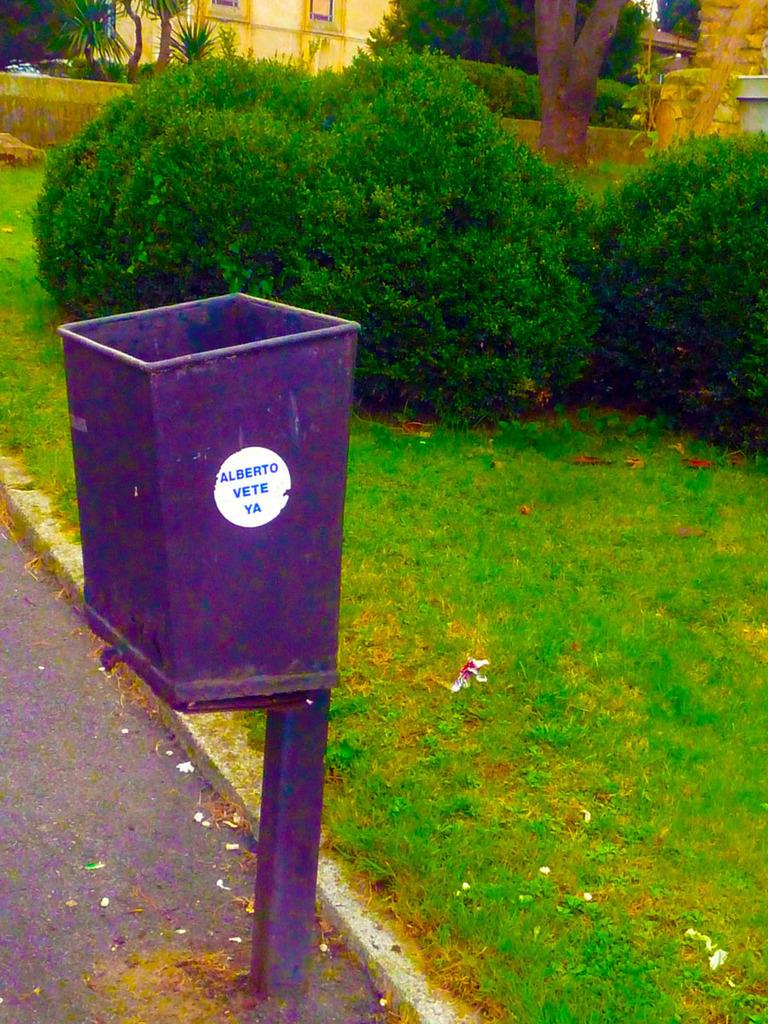What color is the dustbin in the image? The dustbin in the image is violet. What can be seen in the background of the image? In the background of the image, there is grass, plants, trees, and a building. Can you describe the natural elements visible in the image? The natural elements in the image include grass, plants, and trees. How many bananas are hanging from the trees in the image? There are no bananas visible in the image; only trees are present. Can you describe the room where the dustbin is located? There is no room mentioned or visible in the image; it only shows the dustbin and the background. 